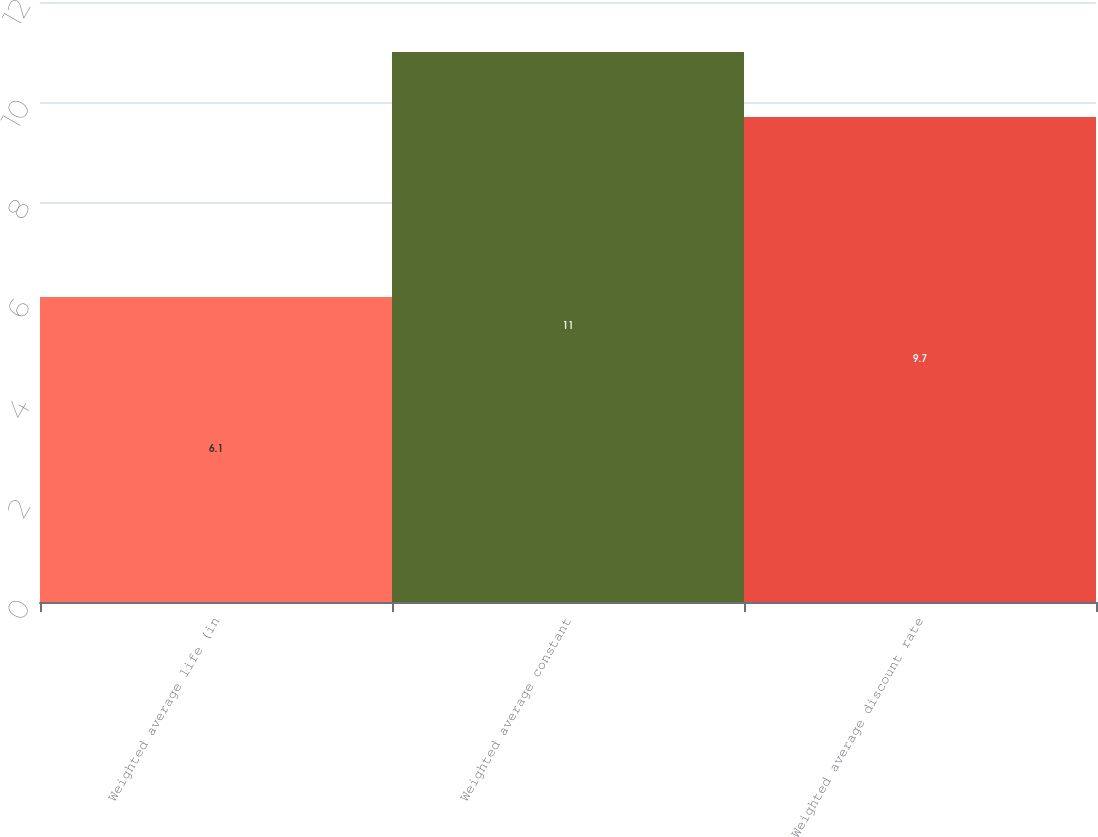<chart> <loc_0><loc_0><loc_500><loc_500><bar_chart><fcel>Weighted average life (in<fcel>Weighted average constant<fcel>Weighted average discount rate<nl><fcel>6.1<fcel>11<fcel>9.7<nl></chart> 